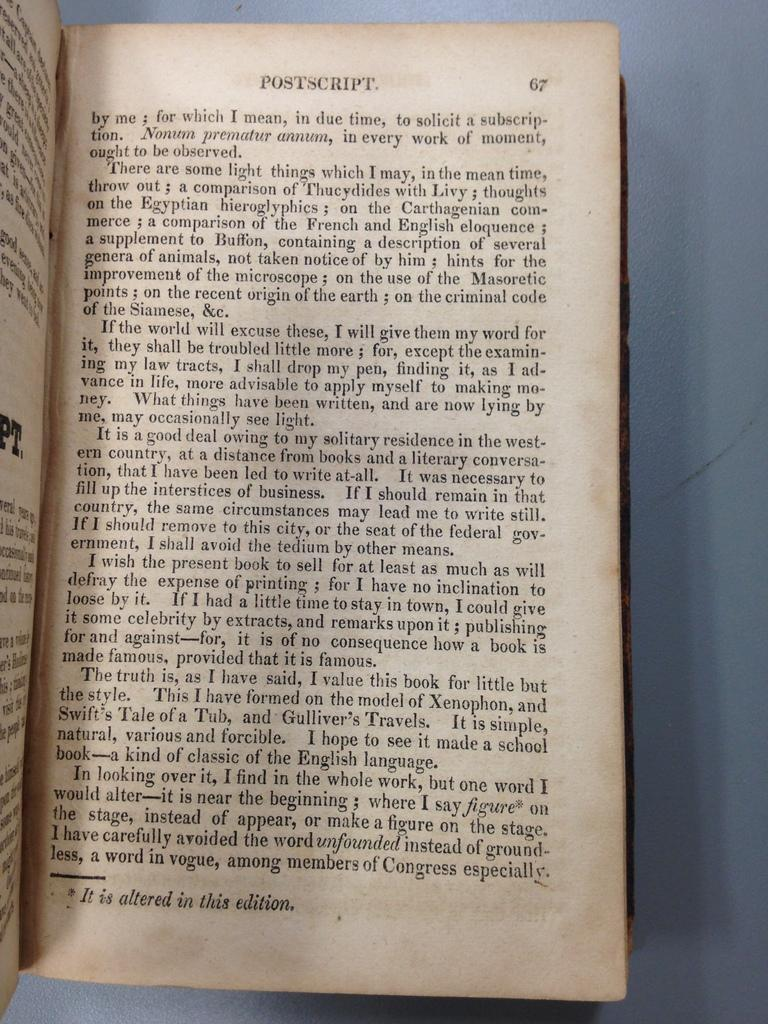<image>
Share a concise interpretation of the image provided. A book with worn pages is open to page sixty seven. 